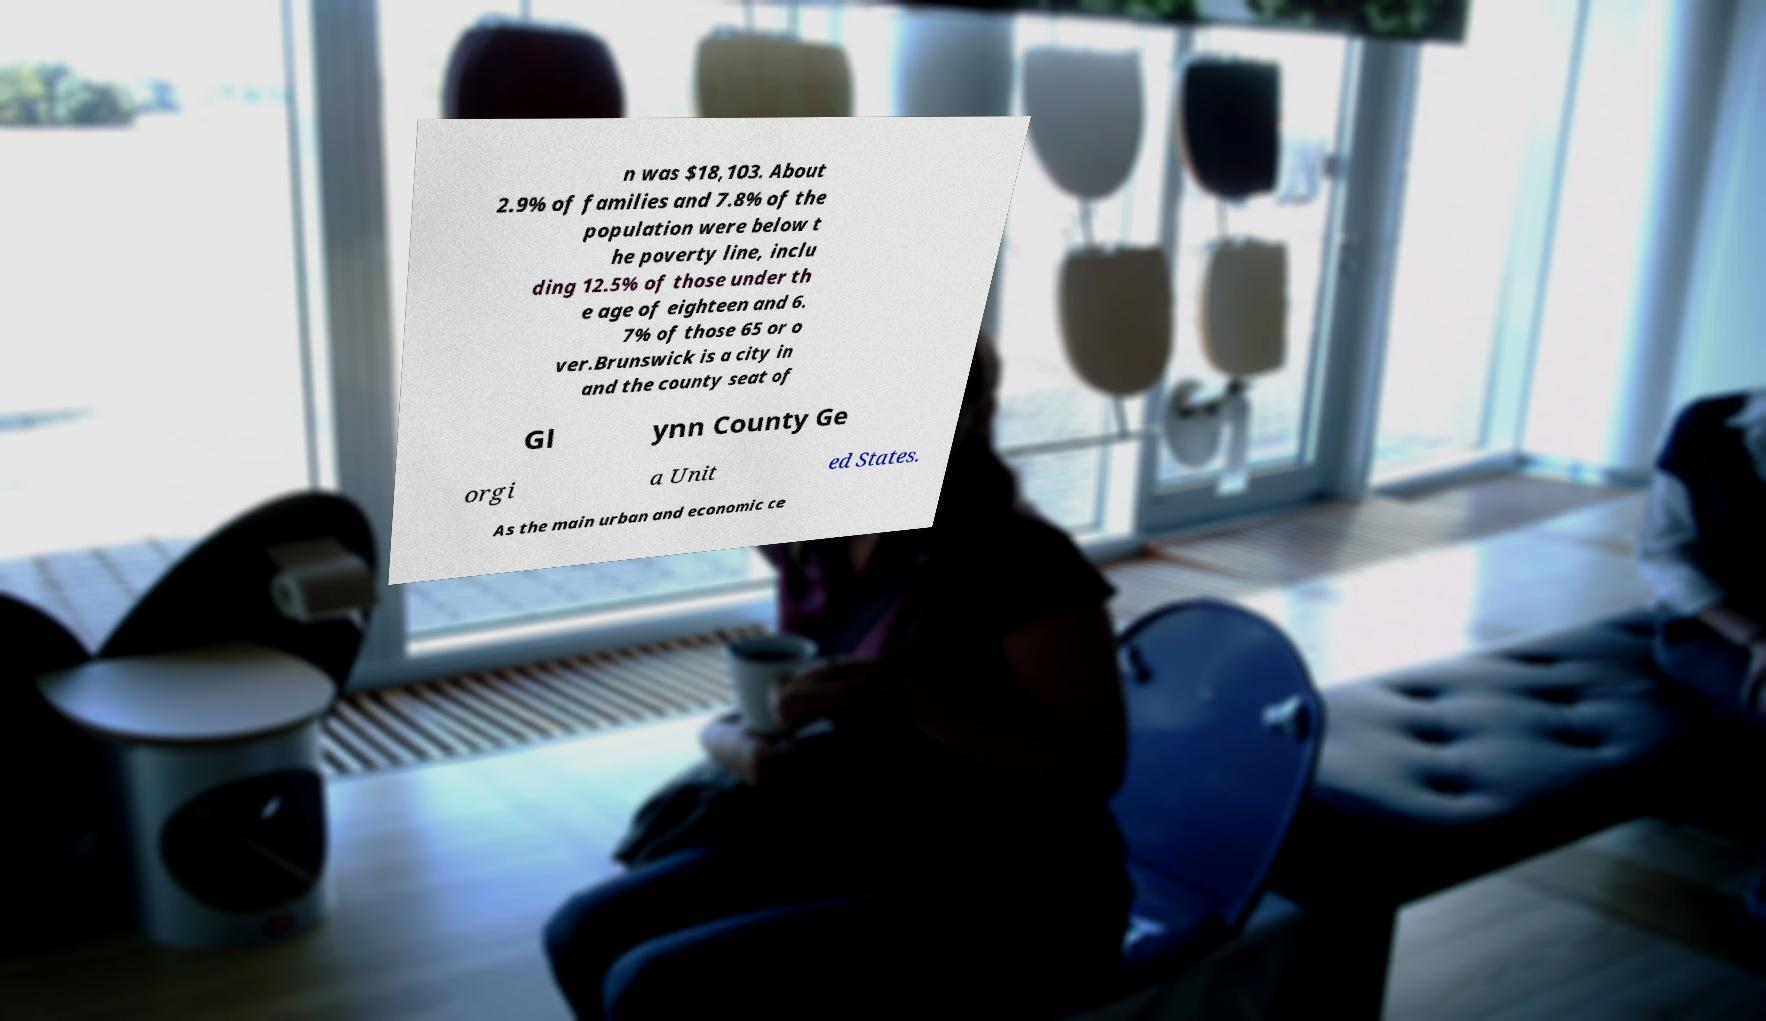Could you assist in decoding the text presented in this image and type it out clearly? n was $18,103. About 2.9% of families and 7.8% of the population were below t he poverty line, inclu ding 12.5% of those under th e age of eighteen and 6. 7% of those 65 or o ver.Brunswick is a city in and the county seat of Gl ynn County Ge orgi a Unit ed States. As the main urban and economic ce 